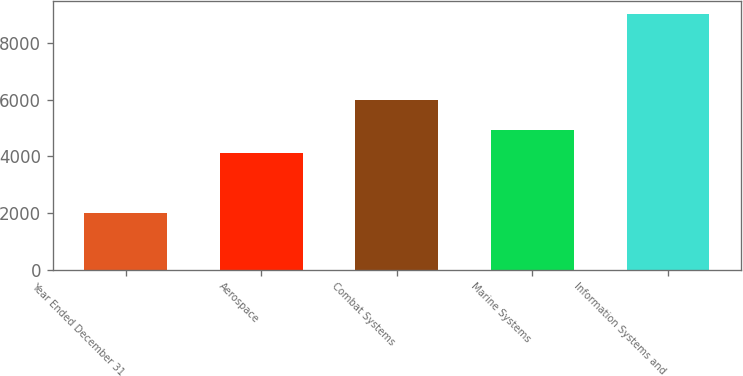Convert chart to OTSL. <chart><loc_0><loc_0><loc_500><loc_500><bar_chart><fcel>Year Ended December 31<fcel>Aerospace<fcel>Combat Systems<fcel>Marine Systems<fcel>Information Systems and<nl><fcel>2006<fcel>4116<fcel>5983<fcel>4940<fcel>9024<nl></chart> 